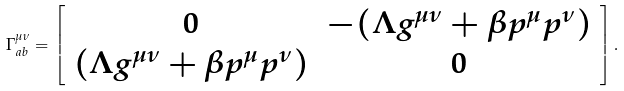Convert formula to latex. <formula><loc_0><loc_0><loc_500><loc_500>\Gamma _ { a b } ^ { \mu \nu } = \left [ { \begin{array} { c c } 0 & - ( \Lambda g ^ { \mu \nu } + \beta p ^ { \mu } p ^ { \nu } ) \\ ( \Lambda g ^ { \mu \nu } + \beta p ^ { \mu } p ^ { \nu } ) & 0 \\ \end{array} } \right ] .</formula> 